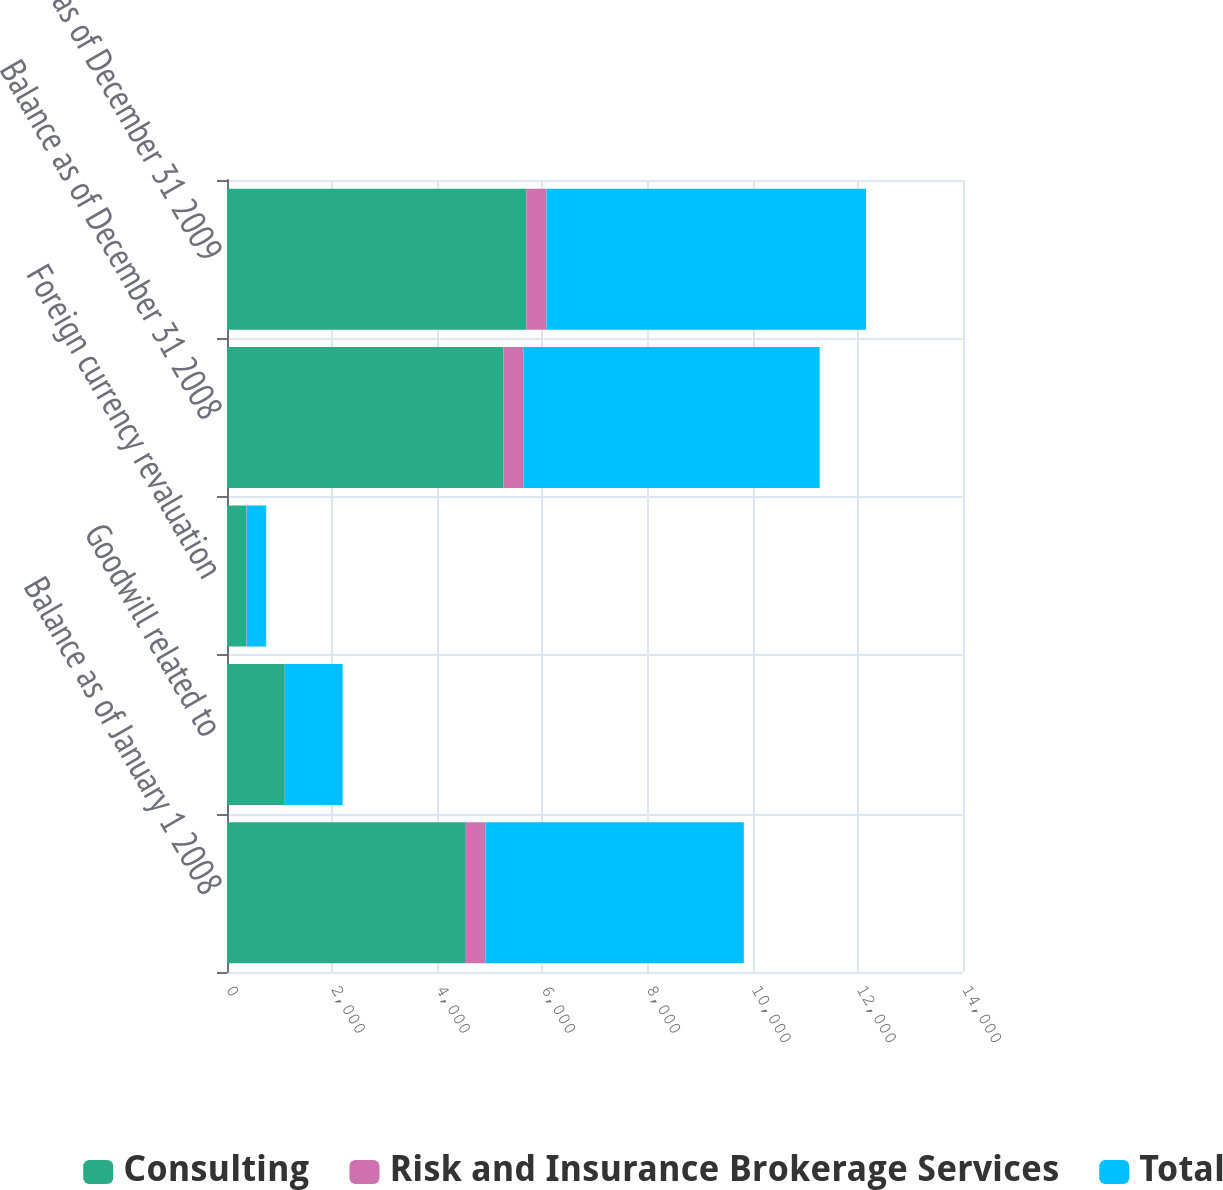Convert chart to OTSL. <chart><loc_0><loc_0><loc_500><loc_500><stacked_bar_chart><ecel><fcel>Balance as of January 1 2008<fcel>Goodwill related to<fcel>Foreign currency revaluation<fcel>Balance as of December 31 2008<fcel>Balance as of December 31 2009<nl><fcel>Consulting<fcel>4527<fcel>1099<fcel>362<fcel>5259<fcel>5693<nl><fcel>Risk and Insurance Brokerage Services<fcel>388<fcel>1<fcel>11<fcel>378<fcel>385<nl><fcel>Total<fcel>4915<fcel>1100<fcel>373<fcel>5637<fcel>6078<nl></chart> 